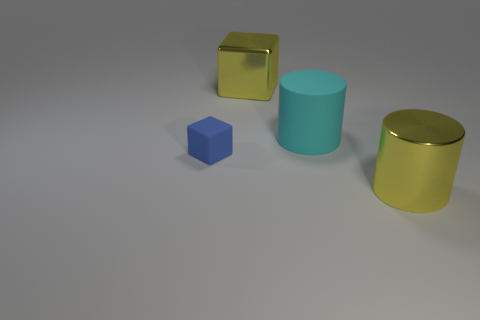Can you describe the lighting and shadows in the scene? The lighting in the scene is soft and diffused, coming from the upper right direction based on the shadows cast. Each object casts a clear, but not overly sharp, shadow to the left, suggesting an environment with potentially a single light source and a wide light angle, giving the scene a calm and even illumination with minimal contrast. 